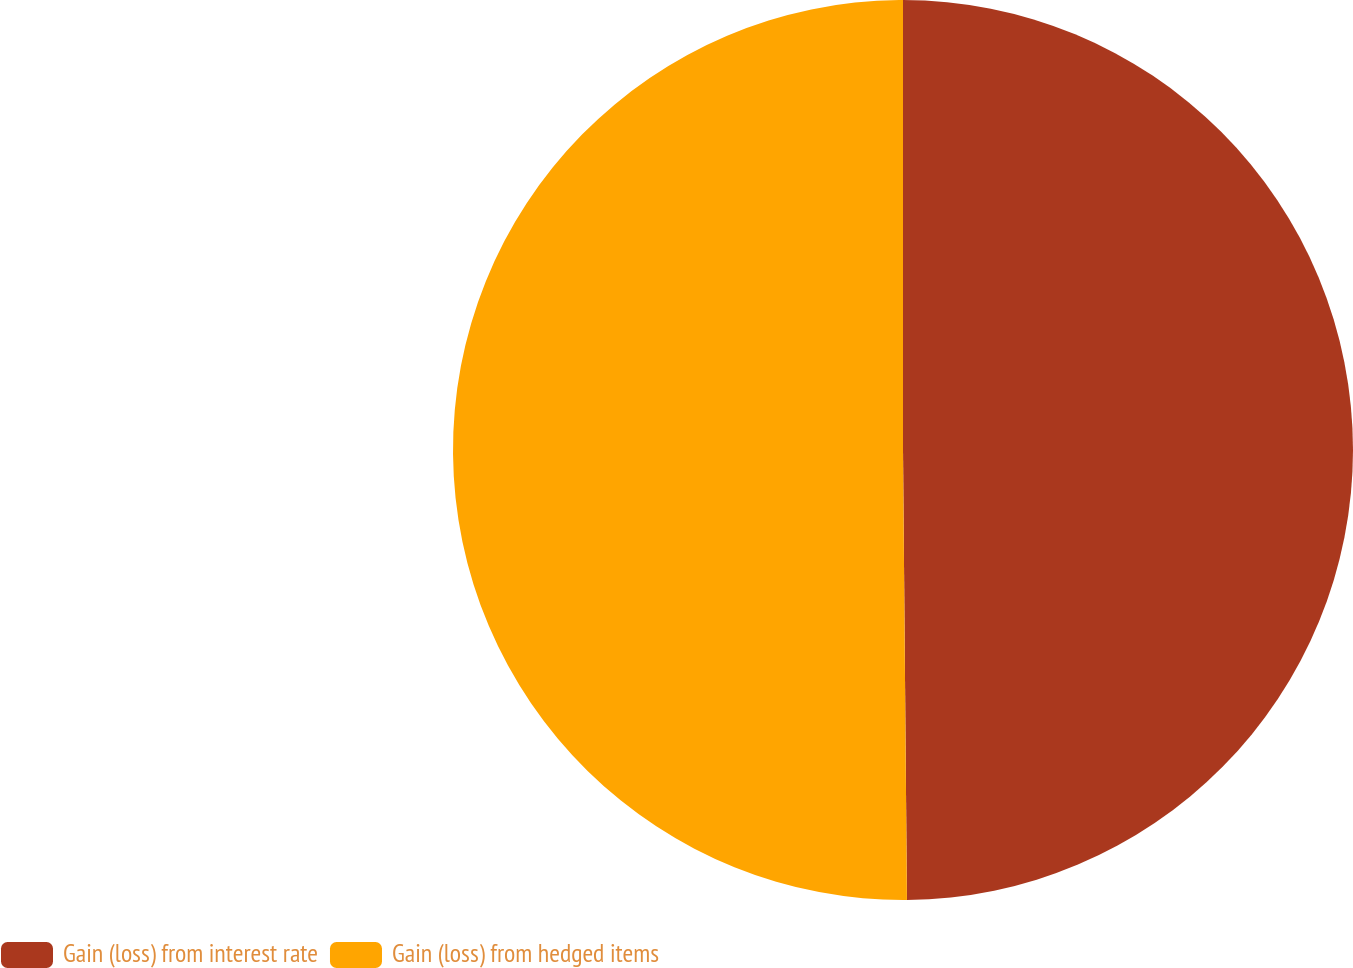Convert chart to OTSL. <chart><loc_0><loc_0><loc_500><loc_500><pie_chart><fcel>Gain (loss) from interest rate<fcel>Gain (loss) from hedged items<nl><fcel>49.86%<fcel>50.14%<nl></chart> 